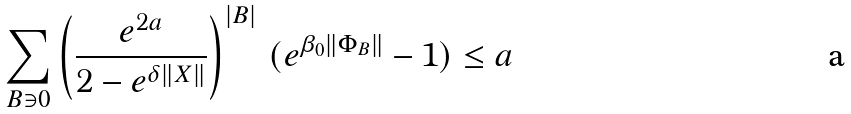<formula> <loc_0><loc_0><loc_500><loc_500>\sum _ { B \ni 0 } \left ( \frac { e ^ { 2 a } } { 2 - e ^ { \delta \| X \| } } \right ) ^ { | B | } \, ( e ^ { \beta _ { 0 } \| \Phi _ { B } \| } - 1 ) \leq a</formula> 